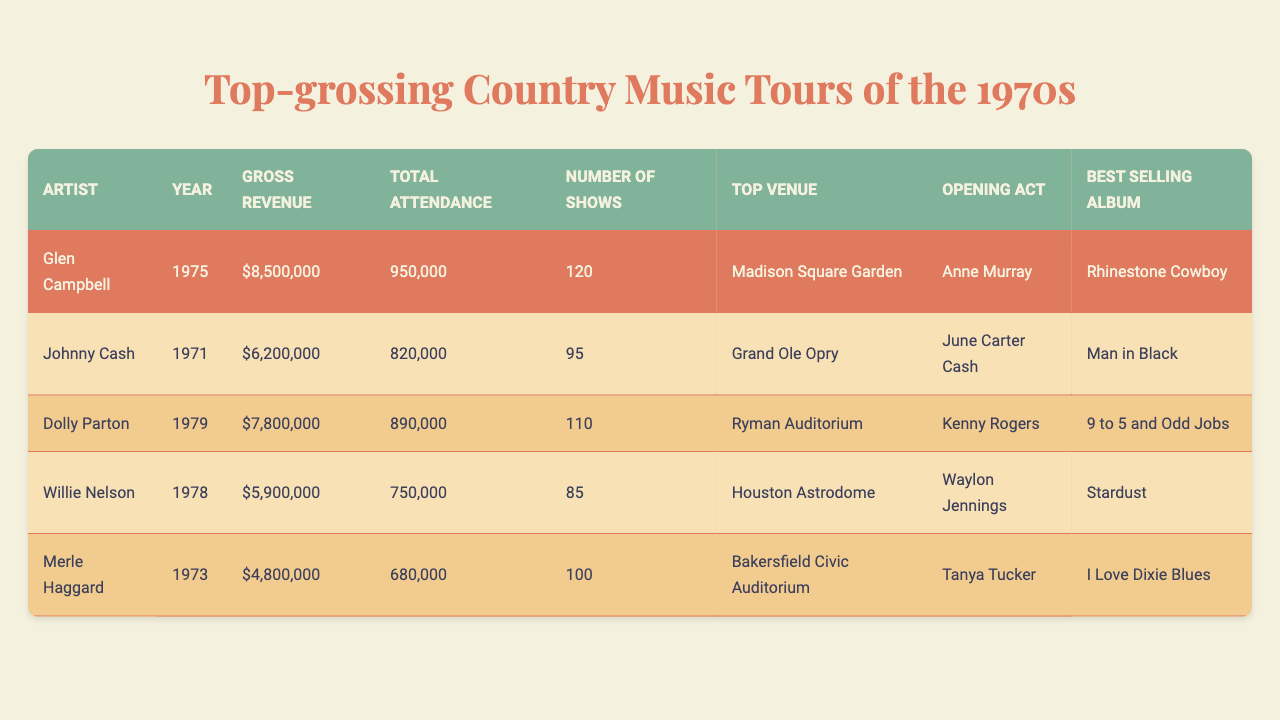What was Glen Campbell's gross revenue from his tour? The table shows that Glen Campbell's gross revenue for his 1975 tour was $8,500,000.
Answer: $8,500,000 Which artist had the highest total attendance during their tour? By reviewing the total attendance figures, Glen Campbell had 950,000 attendees, which is the highest compared to others.
Answer: Glen Campbell How many shows did Dolly Parton perform during her tour? The table indicates that Dolly Parton performed 110 shows in 1979.
Answer: 110 What is the best-selling album of Johnny Cash based on the table? According to the table, Johnny Cash's best-selling album is "Man in Black."
Answer: Man in Black Did any artist have a gross revenue over $7 million? By checking the gross revenue values, only Glen Campbell with $8,500,000 and Dolly Parton with $7,800,000 exceed $7 million. Thus, the answer is yes.
Answer: Yes What was the average gross revenue of all the artists listed? To find the average, add the gross revenues: ($8,500,000 + $6,200,000 + $7,800,000 + $5,900,000 + $4,800,000 = $33,200,000). Then, divide by the number of artists (5), resulting in an average of $6,640,000.
Answer: $6,640,000 Which artist's tour featured an opening act and what was the act? The table lists that Glen Campbell's opening act was Anne Murray, Johnny Cash had June Carter Cash, Dolly Parton had Kenny Rogers, Willie Nelson had Waylon Jennings, and Merle Haggard had Tanya Tucker.
Answer: Multiple artists had opening acts How many more shows did Merle Haggard perform than Willie Nelson? Merle Haggard performed 100 shows and Willie Nelson performed 85 shows. The difference is 100 - 85 = 15.
Answer: 15 shows What was the top venue for Dolly Parton's concert? The table indicates that Dolly Parton's top venue was Ryman Auditorium.
Answer: Ryman Auditorium In which year did Willie Nelson perform his tour? According to the table, Willie Nelson's tour was in the year 1978.
Answer: 1978 